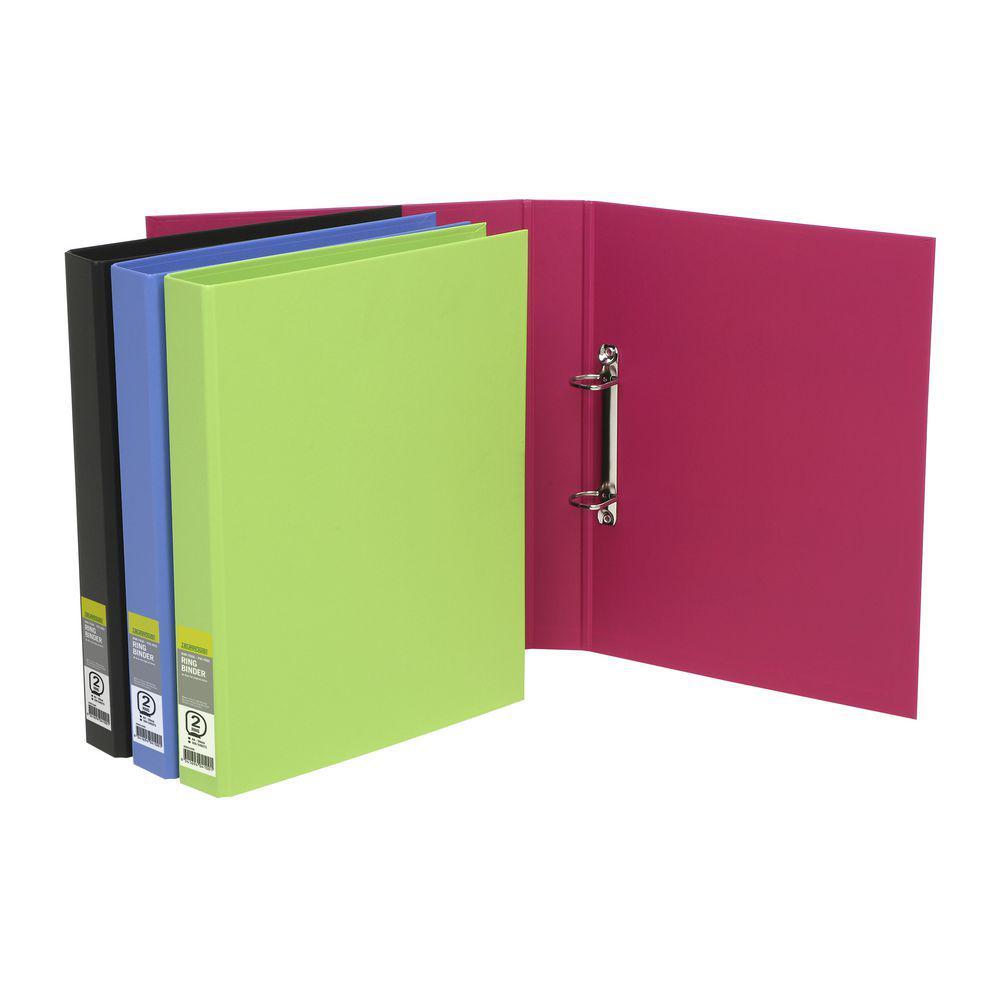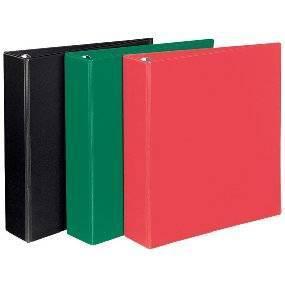The first image is the image on the left, the second image is the image on the right. Examine the images to the left and right. Is the description "One image shows four upright binders of different colors, and the other shows just one upright binder." accurate? Answer yes or no. No. The first image is the image on the left, the second image is the image on the right. For the images shown, is this caption "Five note books, all in different colors, are shown, four in one image all facing the same way, and one in the other image that has a white label on the spine." true? Answer yes or no. No. 